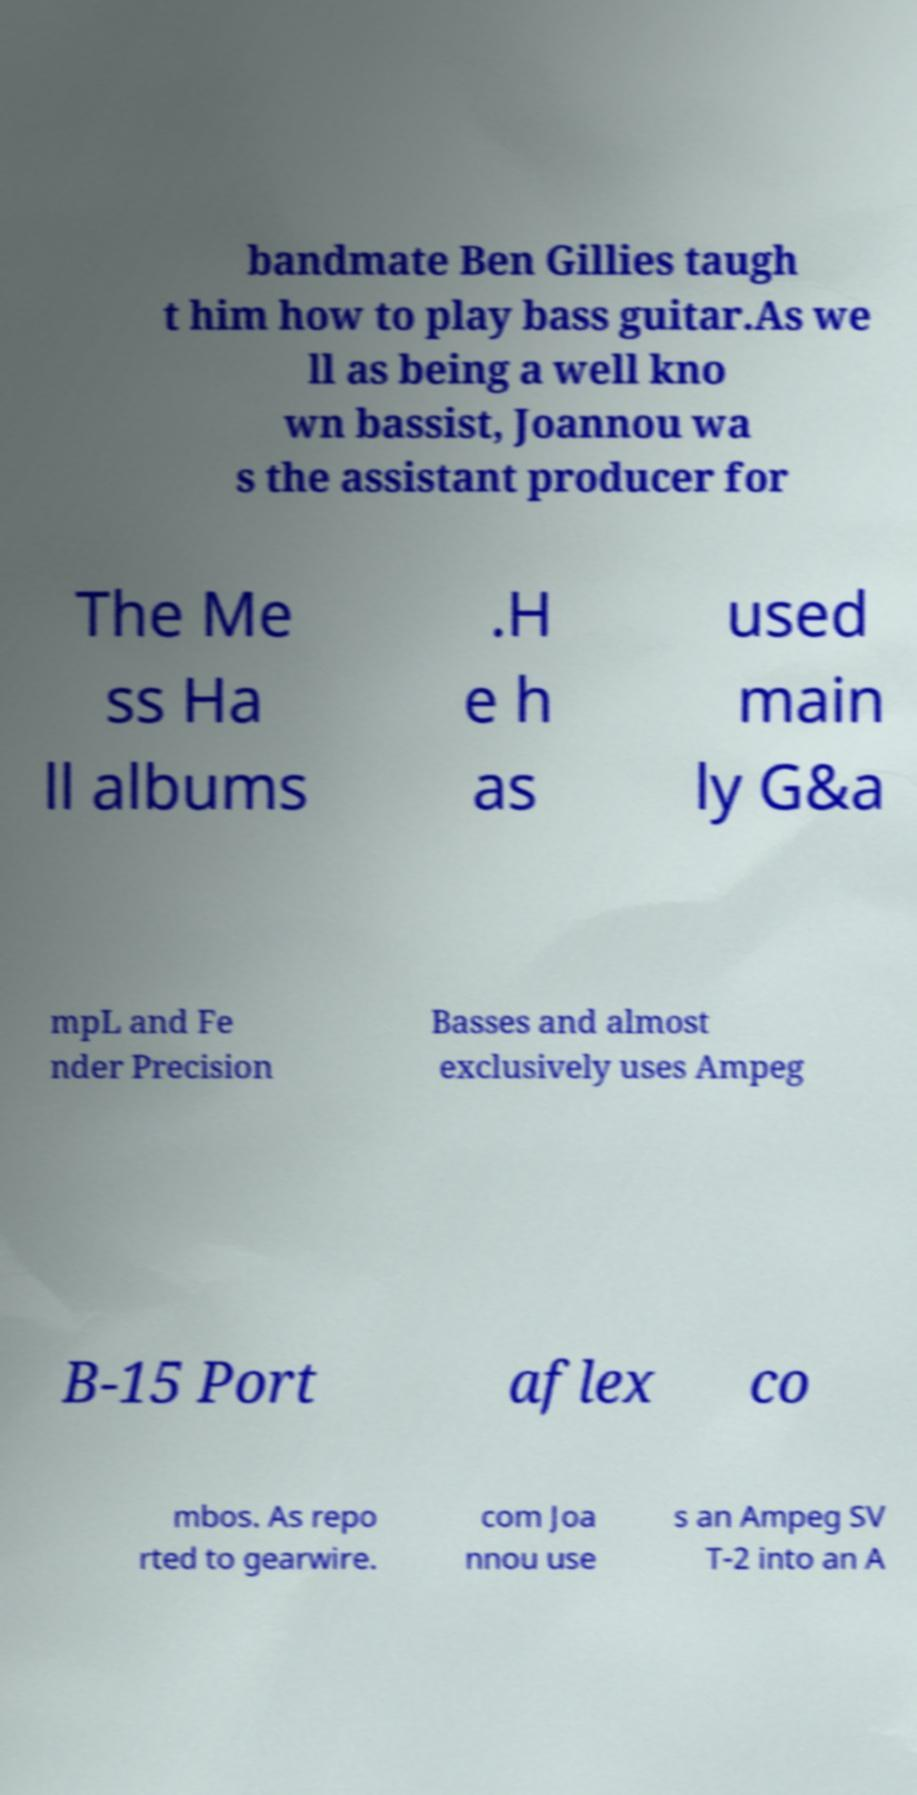Can you read and provide the text displayed in the image?This photo seems to have some interesting text. Can you extract and type it out for me? bandmate Ben Gillies taugh t him how to play bass guitar.As we ll as being a well kno wn bassist, Joannou wa s the assistant producer for The Me ss Ha ll albums .H e h as used main ly G&a mpL and Fe nder Precision Basses and almost exclusively uses Ampeg B-15 Port aflex co mbos. As repo rted to gearwire. com Joa nnou use s an Ampeg SV T-2 into an A 